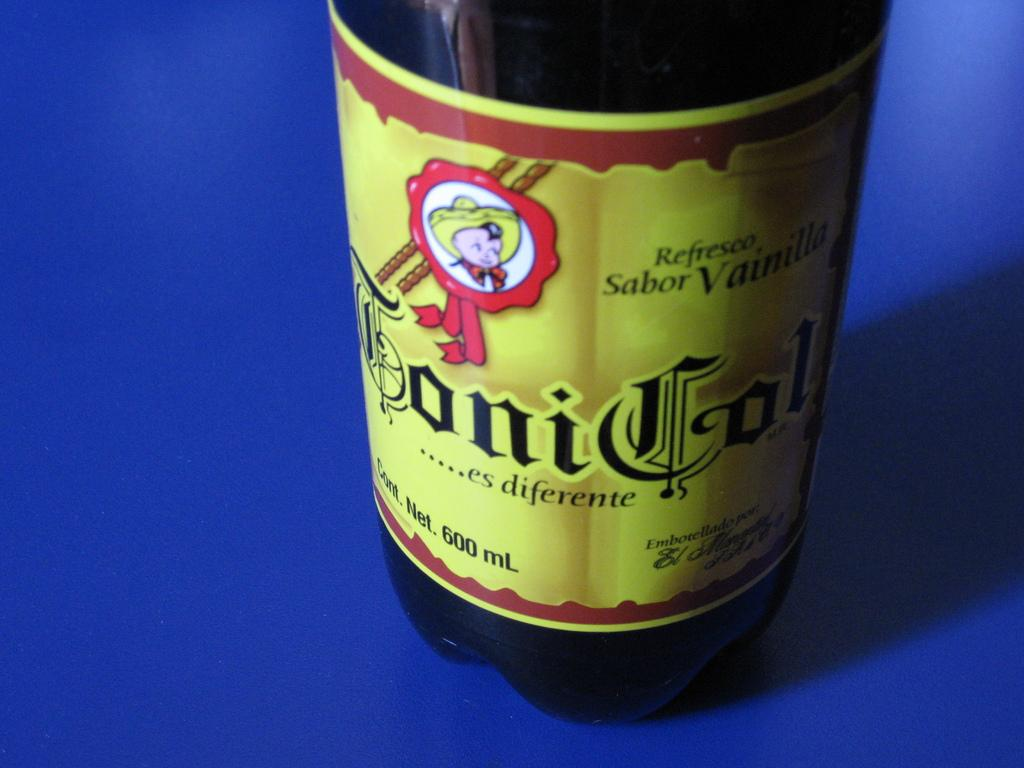What object can be seen in the image? There is a bottle in the image. What color is the background of the image? The background of the image is blue. What type of legal advice is the lawyer giving in the image? There is no lawyer present in the image, so it is not possible to determine what legal advice might be given. 